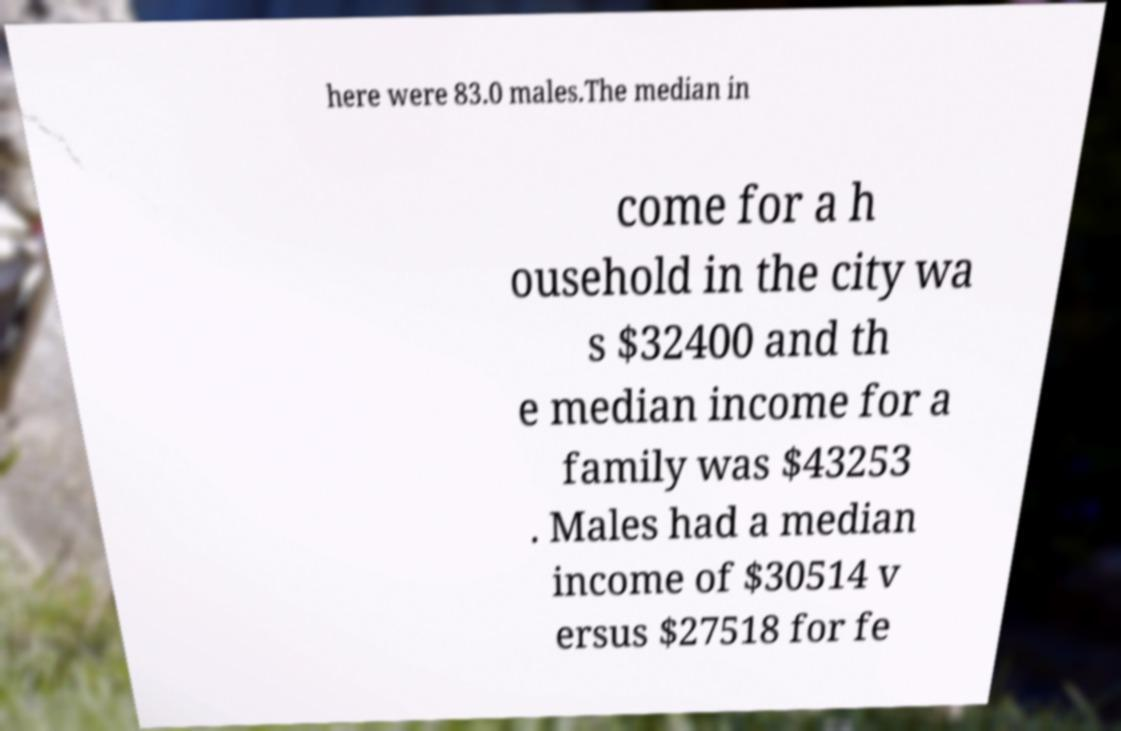Please identify and transcribe the text found in this image. here were 83.0 males.The median in come for a h ousehold in the city wa s $32400 and th e median income for a family was $43253 . Males had a median income of $30514 v ersus $27518 for fe 